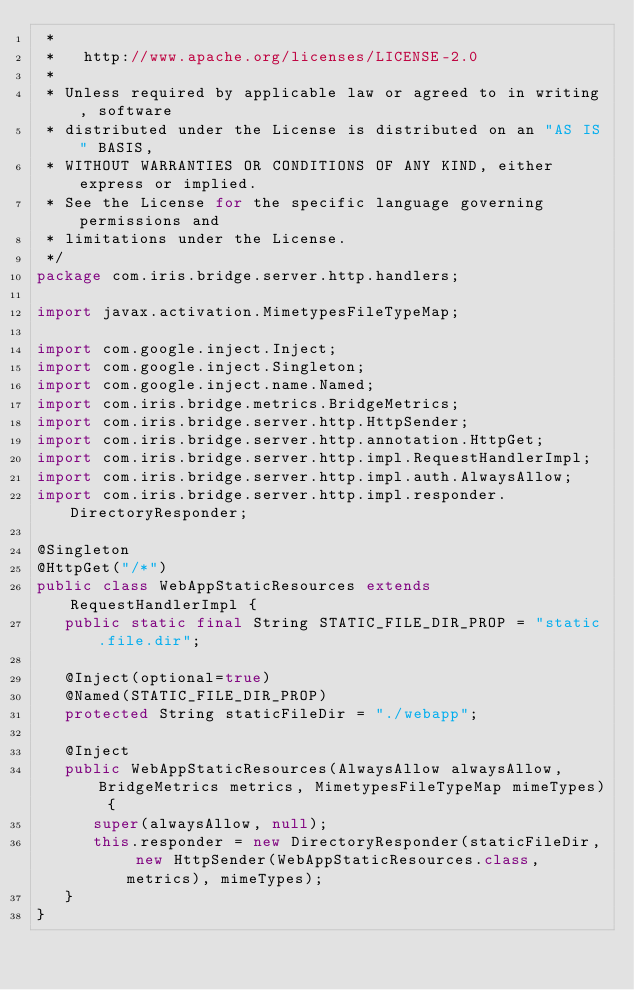Convert code to text. <code><loc_0><loc_0><loc_500><loc_500><_Java_> *
 *   http://www.apache.org/licenses/LICENSE-2.0
 *
 * Unless required by applicable law or agreed to in writing, software
 * distributed under the License is distributed on an "AS IS" BASIS,
 * WITHOUT WARRANTIES OR CONDITIONS OF ANY KIND, either express or implied.
 * See the License for the specific language governing permissions and
 * limitations under the License.
 */
package com.iris.bridge.server.http.handlers;

import javax.activation.MimetypesFileTypeMap;

import com.google.inject.Inject;
import com.google.inject.Singleton;
import com.google.inject.name.Named;
import com.iris.bridge.metrics.BridgeMetrics;
import com.iris.bridge.server.http.HttpSender;
import com.iris.bridge.server.http.annotation.HttpGet;
import com.iris.bridge.server.http.impl.RequestHandlerImpl;
import com.iris.bridge.server.http.impl.auth.AlwaysAllow;
import com.iris.bridge.server.http.impl.responder.DirectoryResponder;

@Singleton
@HttpGet("/*")
public class WebAppStaticResources extends RequestHandlerImpl {
   public static final String STATIC_FILE_DIR_PROP = "static.file.dir";

   @Inject(optional=true)
   @Named(STATIC_FILE_DIR_PROP)
   protected String staticFileDir = "./webapp";

   @Inject
   public WebAppStaticResources(AlwaysAllow alwaysAllow, BridgeMetrics metrics, MimetypesFileTypeMap mimeTypes) {
      super(alwaysAllow, null);
      this.responder = new DirectoryResponder(staticFileDir, new HttpSender(WebAppStaticResources.class, metrics), mimeTypes);
   }
}

</code> 